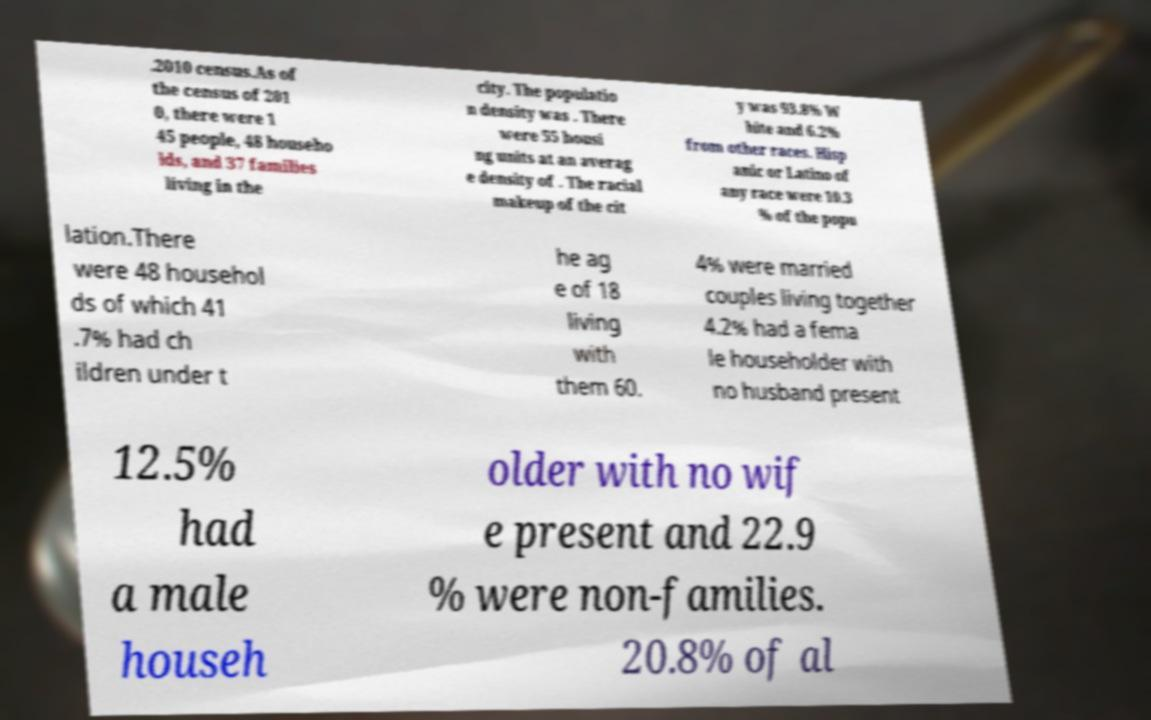For documentation purposes, I need the text within this image transcribed. Could you provide that? .2010 census.As of the census of 201 0, there were 1 45 people, 48 househo lds, and 37 families living in the city. The populatio n density was . There were 55 housi ng units at an averag e density of . The racial makeup of the cit y was 93.8% W hite and 6.2% from other races. Hisp anic or Latino of any race were 10.3 % of the popu lation.There were 48 househol ds of which 41 .7% had ch ildren under t he ag e of 18 living with them 60. 4% were married couples living together 4.2% had a fema le householder with no husband present 12.5% had a male househ older with no wif e present and 22.9 % were non-families. 20.8% of al 